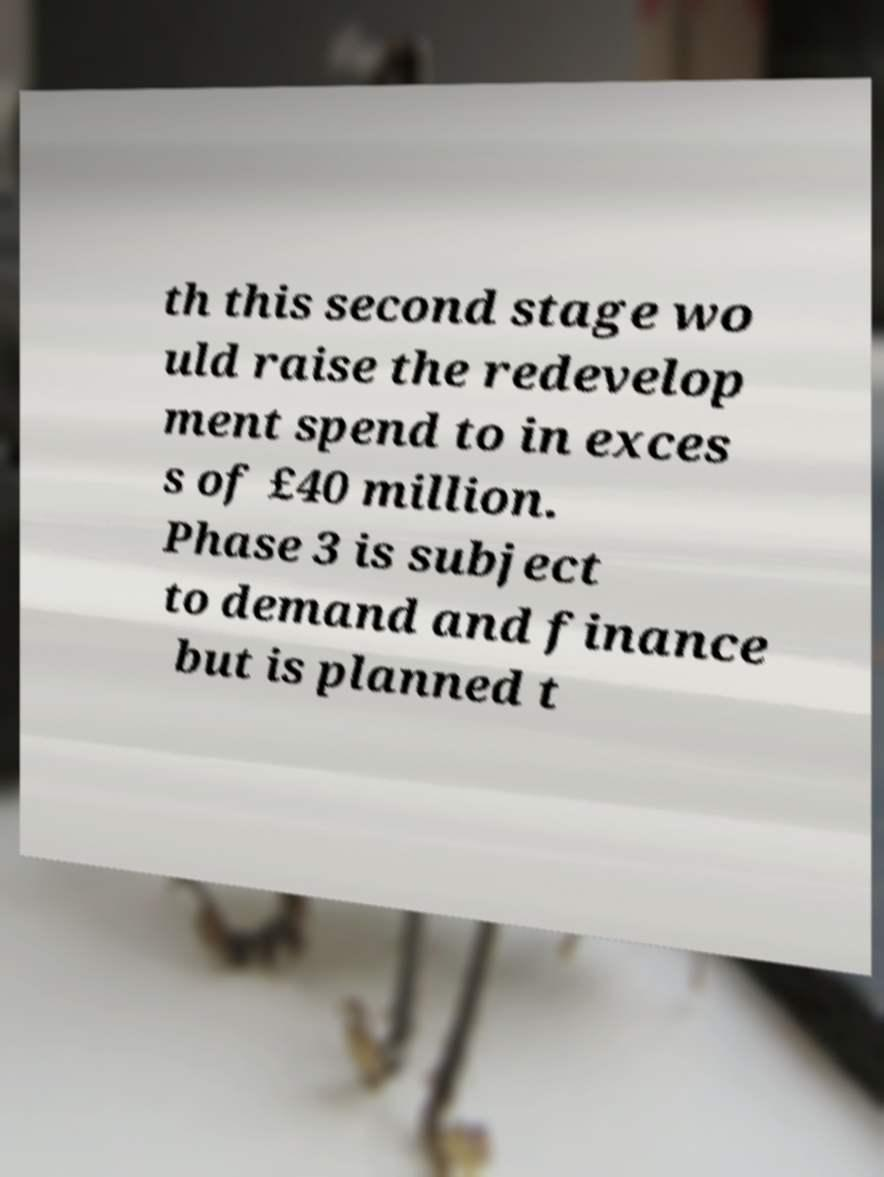I need the written content from this picture converted into text. Can you do that? th this second stage wo uld raise the redevelop ment spend to in exces s of £40 million. Phase 3 is subject to demand and finance but is planned t 